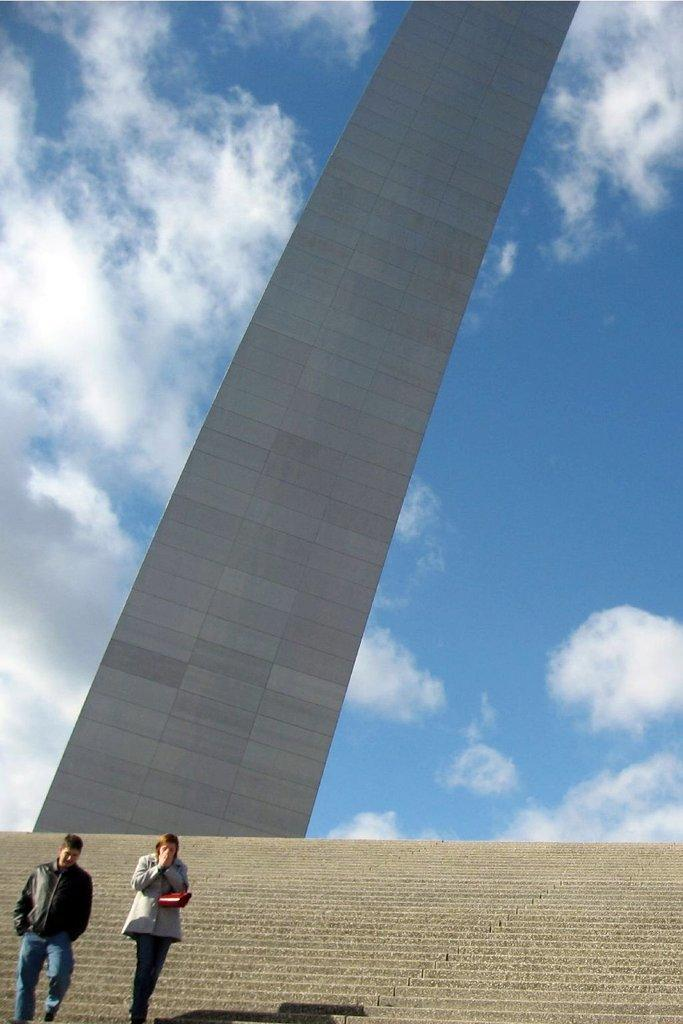What is the main structure in the image? There is a monument in the image. Are there any people present in the image? Yes, there are people in the image. What is one person doing in the image? One person is holding an object. What architectural feature can be seen in the image? There are stairs in the image. What is visible in the sky at the top of the image? Clouds are visible at the top of the image in the sky. Reasoning: Let's think step by step by step in order to produce the conversation. We start by identifying the main structure in the image, which is the monument. Then, we mention the presence of people and describe one person's action, holding an object. Next, we identify an architectural feature, the stairs, and finally, we describe the sky's condition, which includes clouds. Each question is designed to elicit a specific detail about the image that is known from the provided facts. Absurd Question/Answer: What hobbies do the people in the image have, and how do they relate to the pail? There is no pail present in the image, and no information about the people's hobbies is provided. 